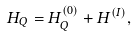Convert formula to latex. <formula><loc_0><loc_0><loc_500><loc_500>H _ { Q } = H _ { Q } ^ { ( 0 ) } + H ^ { ( I ) } ,</formula> 